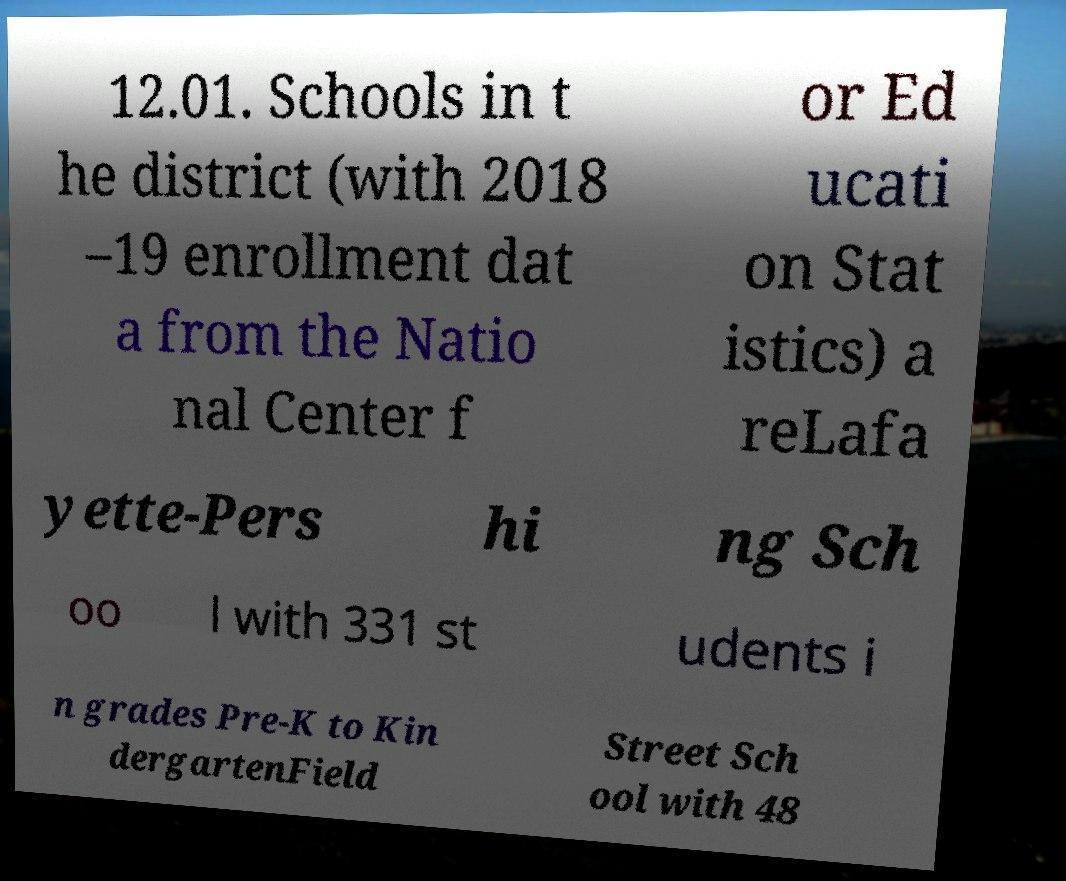What messages or text are displayed in this image? I need them in a readable, typed format. 12.01. Schools in t he district (with 2018 –19 enrollment dat a from the Natio nal Center f or Ed ucati on Stat istics) a reLafa yette-Pers hi ng Sch oo l with 331 st udents i n grades Pre-K to Kin dergartenField Street Sch ool with 48 